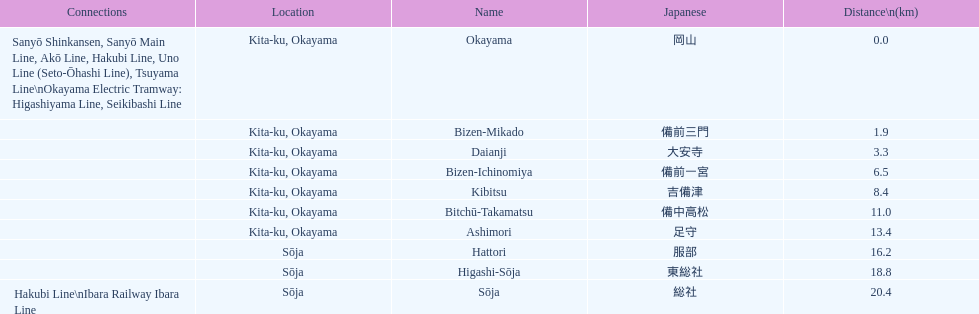Which has a distance of more than 1 kilometer but less than 2 kilometers? Bizen-Mikado. 